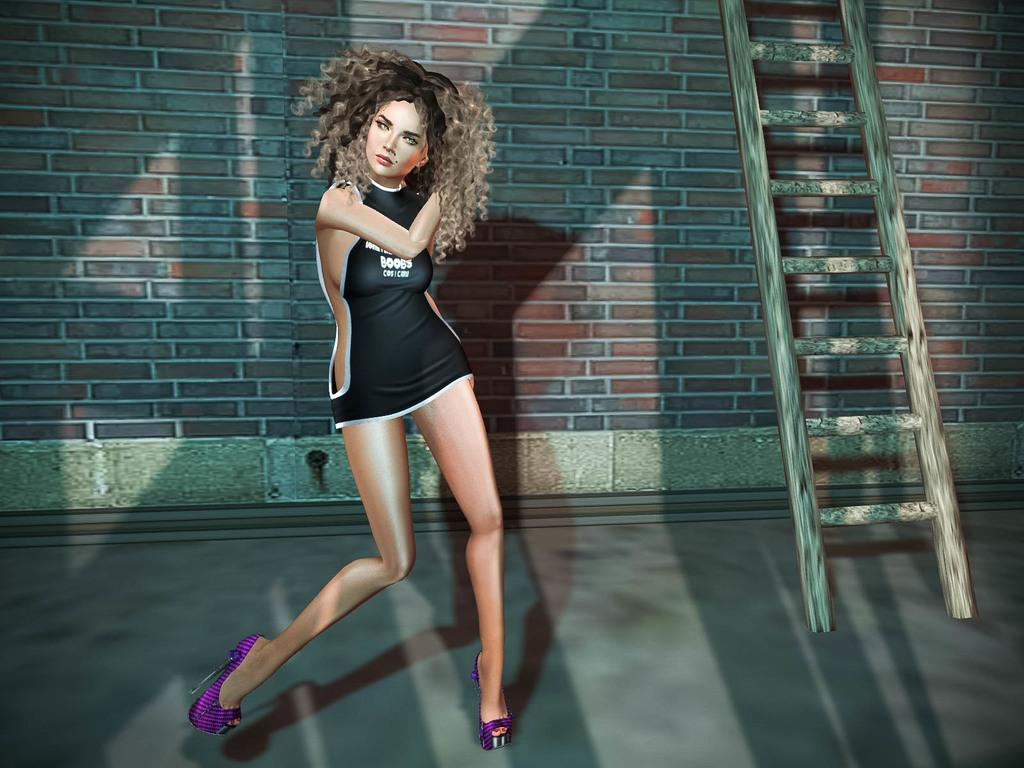<image>
Write a terse but informative summary of the picture. A woman dances whilst wearing a short dress with Boobs written on it 